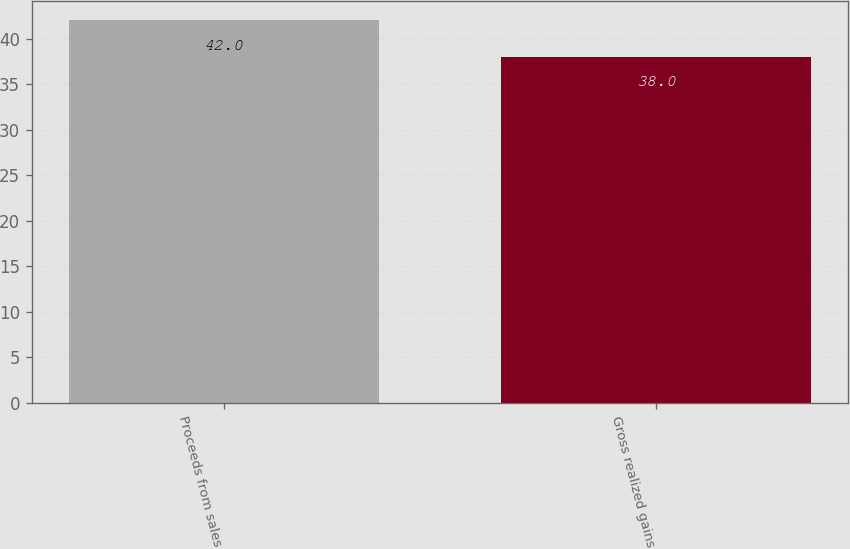<chart> <loc_0><loc_0><loc_500><loc_500><bar_chart><fcel>Proceeds from sales<fcel>Gross realized gains<nl><fcel>42<fcel>38<nl></chart> 